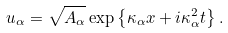<formula> <loc_0><loc_0><loc_500><loc_500>u _ { \alpha } = \sqrt { A _ { \alpha } } \exp \left \{ \kappa _ { \alpha } x + i \kappa _ { \alpha } ^ { 2 } t \right \} .</formula> 